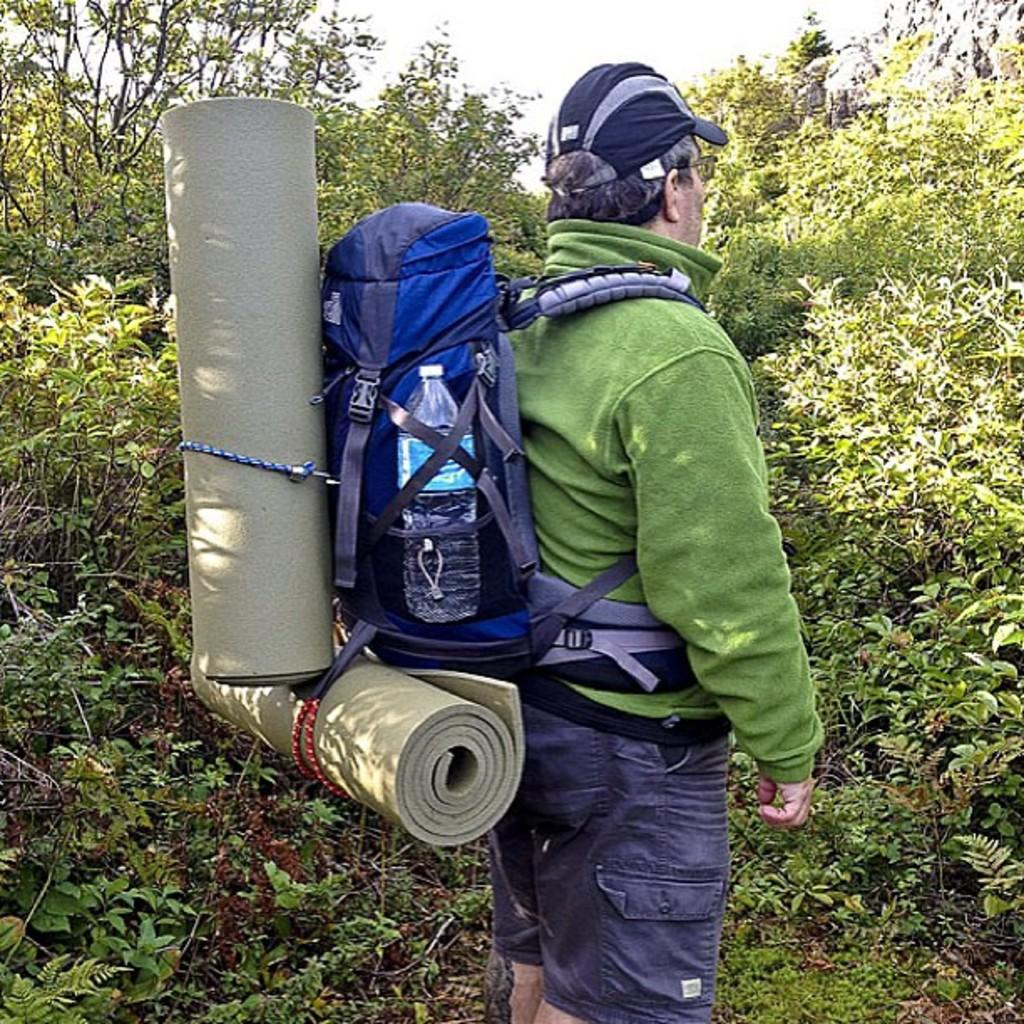What is the man in the image wearing? The man is wearing a green jacket and a cap. What items is the man carrying in the image? The man is carrying a bag and a bottle. What can be seen at the man's back in the image? There are sheets visible at the man's back. What is visible in the background of the image? There are trees in the background of the image. How far away is the instrument in the image? There is no instrument present in the image. --- Facts: 1. There is a car in the image. 2. The car is red. 3. The car has four wheels. 4. The car has a license plate. 5. The car is parked on the street. Absurd Topics: ocean Conversation: What type of vehicle is in the image? There is a car in the image. What color is the car in the image? The car is red in the image. How many wheels does the car have in the image? The car has four wheels in the image. Can you see the license plate of the car in the image? Yes, the car has a license plate in the image. Where is the car located in the image? The car is parked on the street in the image. Reasoning: Let's think step by step in order to produce the conversation. We start by identifying the main subject of the image, which is the car. Next, we describe specific features of the car, such as its color, the number of wheels it has, and the presence of a license plate. Then, we observe the location of the car in the image, which is parked on the street. Each question is designed to elicit a specific detail about the image that is known from the provided facts. Absurd Question/Answer: Can you see the ocean in the image? No, the ocean is not present in the image. The image only shows a red car parked on the street. --- Facts: 1. There is a group of people in the image. 2. The group of people is standing in a circle. 3. The group of people is holding hands. 4. The group of people is wearing matching t-shirts. 5. The group of people is standing in front of a building. Absurd Topics: animal Conversation: How many people are in the image? There is a group of people in the image. What are the people in the image doing? The group of people is standing in a circle in the image. How are the people in the image connected? The group of people is holding hands in the image. What are the people in the image wearing? The group of people is wearing matching t-shirts in the image. What can be seen behind the group of people in the image? The group of 